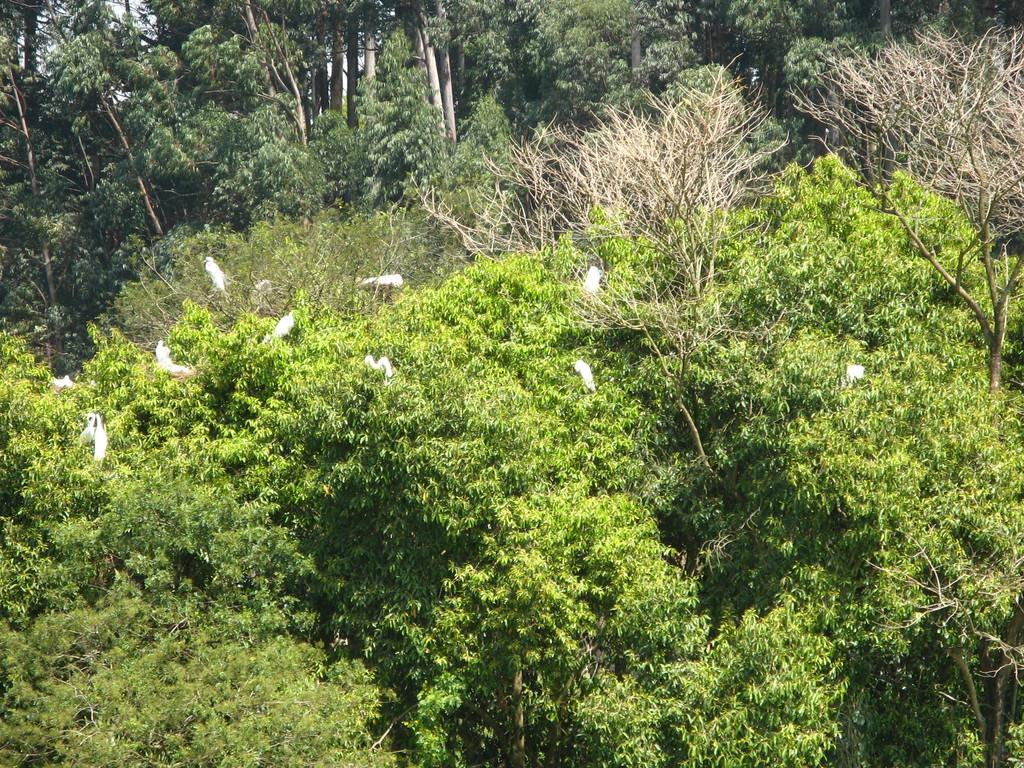What type of vegetation is present in the image? There are trees in the image. What can be seen on the trees? There are birds on the trees. What color are the birds? The birds are white in color. How does the ink on the trees affect the birds in the image? There is no ink present in the image, so it does not affect the birds. 